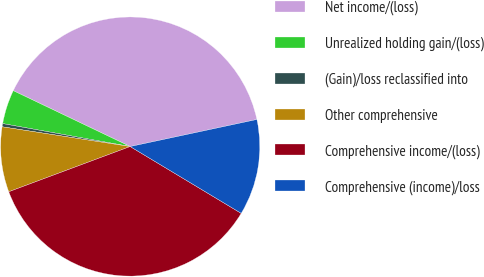Convert chart to OTSL. <chart><loc_0><loc_0><loc_500><loc_500><pie_chart><fcel>Net income/(loss)<fcel>Unrealized holding gain/(loss)<fcel>(Gain)/loss reclassified into<fcel>Other comprehensive<fcel>Comprehensive income/(loss)<fcel>Comprehensive (income)/loss<nl><fcel>39.55%<fcel>4.26%<fcel>0.4%<fcel>8.11%<fcel>35.7%<fcel>11.97%<nl></chart> 